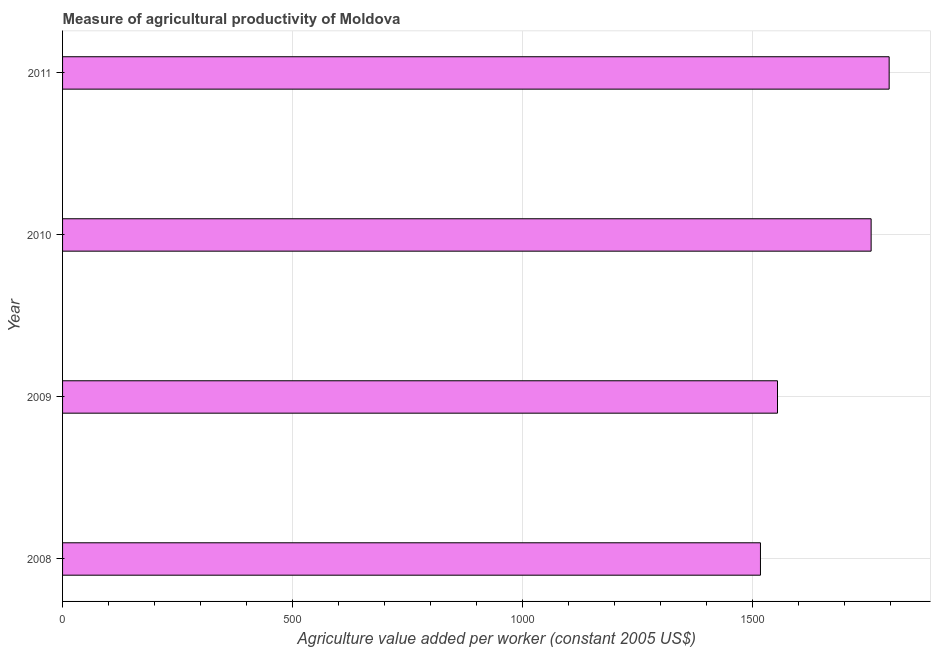Does the graph contain any zero values?
Provide a short and direct response. No. Does the graph contain grids?
Keep it short and to the point. Yes. What is the title of the graph?
Keep it short and to the point. Measure of agricultural productivity of Moldova. What is the label or title of the X-axis?
Give a very brief answer. Agriculture value added per worker (constant 2005 US$). What is the agriculture value added per worker in 2010?
Your answer should be compact. 1757.42. Across all years, what is the maximum agriculture value added per worker?
Your answer should be very brief. 1796.64. Across all years, what is the minimum agriculture value added per worker?
Offer a terse response. 1516.87. In which year was the agriculture value added per worker minimum?
Your response must be concise. 2008. What is the sum of the agriculture value added per worker?
Your answer should be very brief. 6624.86. What is the difference between the agriculture value added per worker in 2008 and 2010?
Ensure brevity in your answer.  -240.55. What is the average agriculture value added per worker per year?
Keep it short and to the point. 1656.21. What is the median agriculture value added per worker?
Your answer should be compact. 1655.68. In how many years, is the agriculture value added per worker greater than 100 US$?
Provide a succinct answer. 4. What is the ratio of the agriculture value added per worker in 2009 to that in 2011?
Make the answer very short. 0.86. Is the difference between the agriculture value added per worker in 2010 and 2011 greater than the difference between any two years?
Keep it short and to the point. No. What is the difference between the highest and the second highest agriculture value added per worker?
Your response must be concise. 39.22. Is the sum of the agriculture value added per worker in 2010 and 2011 greater than the maximum agriculture value added per worker across all years?
Keep it short and to the point. Yes. What is the difference between the highest and the lowest agriculture value added per worker?
Give a very brief answer. 279.76. How many bars are there?
Provide a succinct answer. 4. Are all the bars in the graph horizontal?
Provide a short and direct response. Yes. Are the values on the major ticks of X-axis written in scientific E-notation?
Your response must be concise. No. What is the Agriculture value added per worker (constant 2005 US$) in 2008?
Offer a very short reply. 1516.87. What is the Agriculture value added per worker (constant 2005 US$) of 2009?
Your response must be concise. 1553.93. What is the Agriculture value added per worker (constant 2005 US$) of 2010?
Offer a terse response. 1757.42. What is the Agriculture value added per worker (constant 2005 US$) in 2011?
Offer a terse response. 1796.64. What is the difference between the Agriculture value added per worker (constant 2005 US$) in 2008 and 2009?
Make the answer very short. -37.05. What is the difference between the Agriculture value added per worker (constant 2005 US$) in 2008 and 2010?
Provide a short and direct response. -240.55. What is the difference between the Agriculture value added per worker (constant 2005 US$) in 2008 and 2011?
Provide a succinct answer. -279.76. What is the difference between the Agriculture value added per worker (constant 2005 US$) in 2009 and 2010?
Provide a short and direct response. -203.49. What is the difference between the Agriculture value added per worker (constant 2005 US$) in 2009 and 2011?
Keep it short and to the point. -242.71. What is the difference between the Agriculture value added per worker (constant 2005 US$) in 2010 and 2011?
Offer a very short reply. -39.22. What is the ratio of the Agriculture value added per worker (constant 2005 US$) in 2008 to that in 2009?
Provide a succinct answer. 0.98. What is the ratio of the Agriculture value added per worker (constant 2005 US$) in 2008 to that in 2010?
Offer a terse response. 0.86. What is the ratio of the Agriculture value added per worker (constant 2005 US$) in 2008 to that in 2011?
Offer a very short reply. 0.84. What is the ratio of the Agriculture value added per worker (constant 2005 US$) in 2009 to that in 2010?
Your response must be concise. 0.88. What is the ratio of the Agriculture value added per worker (constant 2005 US$) in 2009 to that in 2011?
Provide a short and direct response. 0.86. 